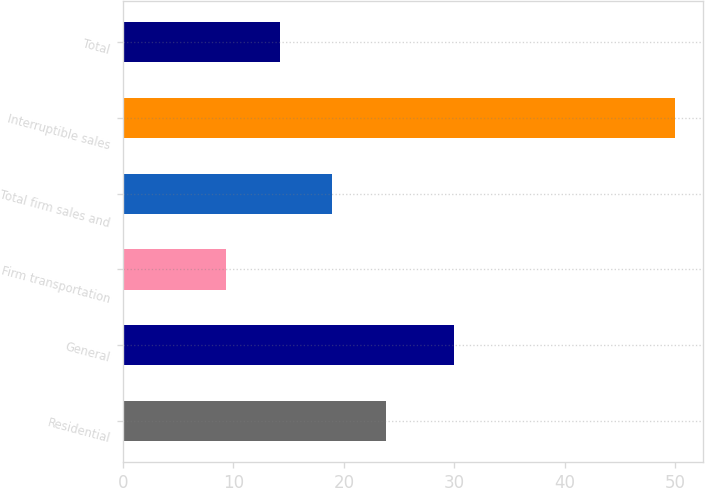<chart> <loc_0><loc_0><loc_500><loc_500><bar_chart><fcel>Residential<fcel>General<fcel>Firm transportation<fcel>Total firm sales and<fcel>Interruptible sales<fcel>Total<nl><fcel>23.8<fcel>30<fcel>9.3<fcel>18.9<fcel>50<fcel>14.2<nl></chart> 